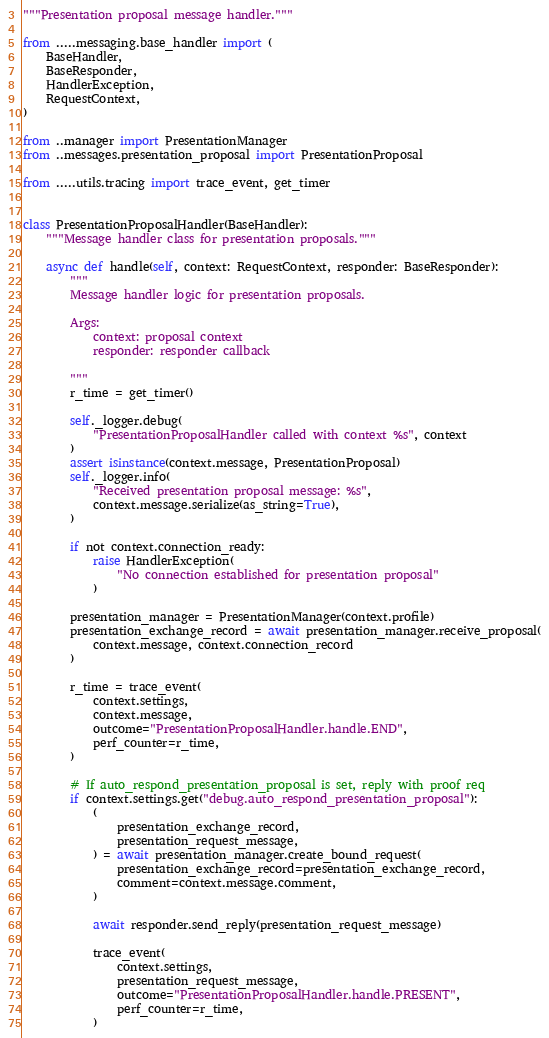Convert code to text. <code><loc_0><loc_0><loc_500><loc_500><_Python_>"""Presentation proposal message handler."""

from .....messaging.base_handler import (
    BaseHandler,
    BaseResponder,
    HandlerException,
    RequestContext,
)

from ..manager import PresentationManager
from ..messages.presentation_proposal import PresentationProposal

from .....utils.tracing import trace_event, get_timer


class PresentationProposalHandler(BaseHandler):
    """Message handler class for presentation proposals."""

    async def handle(self, context: RequestContext, responder: BaseResponder):
        """
        Message handler logic for presentation proposals.

        Args:
            context: proposal context
            responder: responder callback

        """
        r_time = get_timer()

        self._logger.debug(
            "PresentationProposalHandler called with context %s", context
        )
        assert isinstance(context.message, PresentationProposal)
        self._logger.info(
            "Received presentation proposal message: %s",
            context.message.serialize(as_string=True),
        )

        if not context.connection_ready:
            raise HandlerException(
                "No connection established for presentation proposal"
            )

        presentation_manager = PresentationManager(context.profile)
        presentation_exchange_record = await presentation_manager.receive_proposal(
            context.message, context.connection_record
        )

        r_time = trace_event(
            context.settings,
            context.message,
            outcome="PresentationProposalHandler.handle.END",
            perf_counter=r_time,
        )

        # If auto_respond_presentation_proposal is set, reply with proof req
        if context.settings.get("debug.auto_respond_presentation_proposal"):
            (
                presentation_exchange_record,
                presentation_request_message,
            ) = await presentation_manager.create_bound_request(
                presentation_exchange_record=presentation_exchange_record,
                comment=context.message.comment,
            )

            await responder.send_reply(presentation_request_message)

            trace_event(
                context.settings,
                presentation_request_message,
                outcome="PresentationProposalHandler.handle.PRESENT",
                perf_counter=r_time,
            )
</code> 